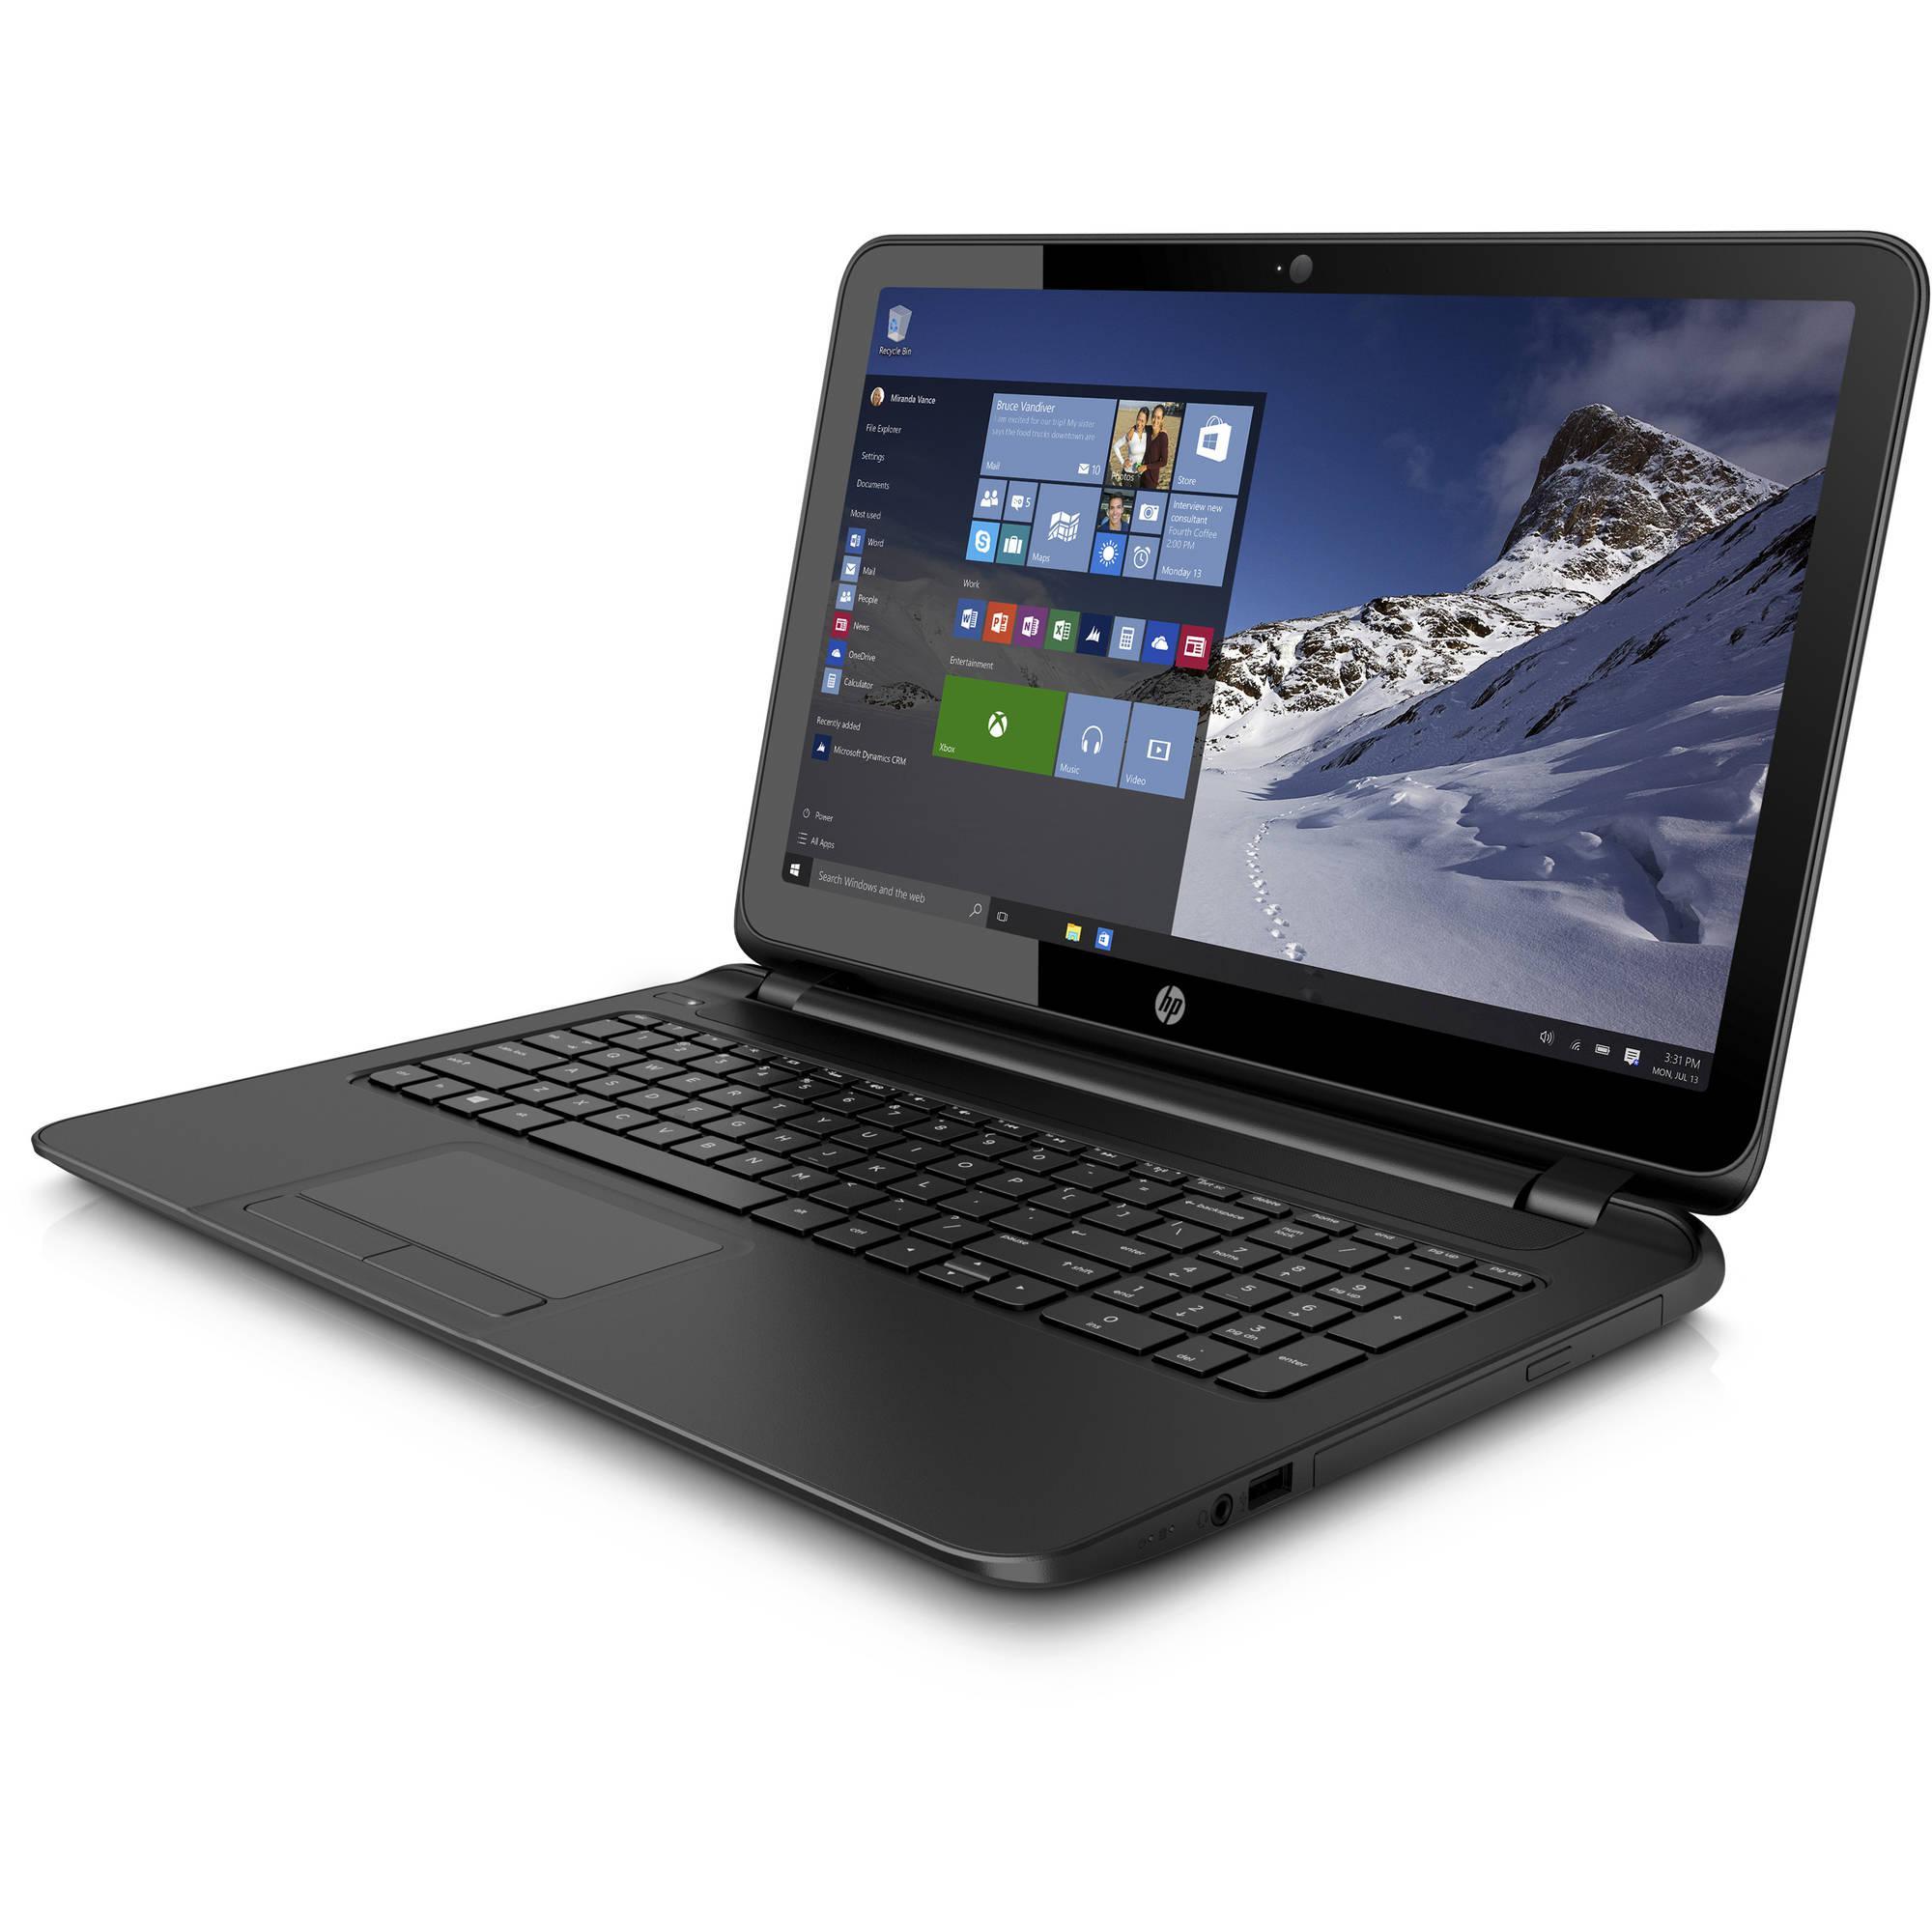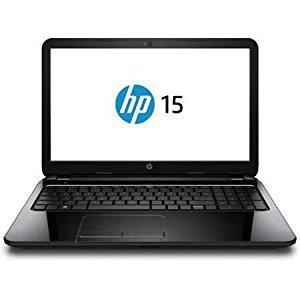The first image is the image on the left, the second image is the image on the right. Evaluate the accuracy of this statement regarding the images: "One laptop screen shows the HP logo and the other shows a windows desktop with a picture of a snowy mountain.". Is it true? Answer yes or no. Yes. 